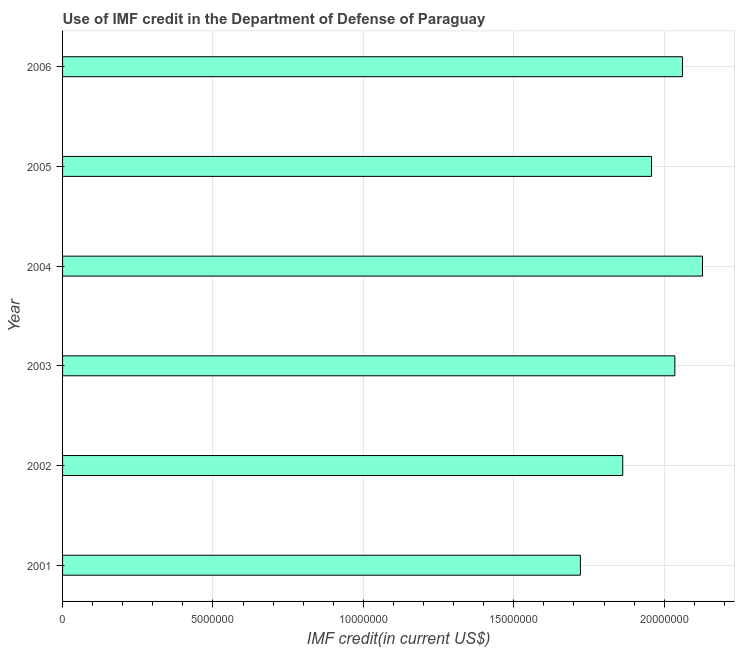Does the graph contain any zero values?
Offer a terse response. No. Does the graph contain grids?
Offer a terse response. Yes. What is the title of the graph?
Ensure brevity in your answer.  Use of IMF credit in the Department of Defense of Paraguay. What is the label or title of the X-axis?
Offer a very short reply. IMF credit(in current US$). What is the use of imf credit in dod in 2001?
Provide a succinct answer. 1.72e+07. Across all years, what is the maximum use of imf credit in dod?
Your answer should be very brief. 2.13e+07. Across all years, what is the minimum use of imf credit in dod?
Give a very brief answer. 1.72e+07. In which year was the use of imf credit in dod maximum?
Your response must be concise. 2004. What is the sum of the use of imf credit in dod?
Give a very brief answer. 1.18e+08. What is the difference between the use of imf credit in dod in 2003 and 2004?
Provide a succinct answer. -9.19e+05. What is the average use of imf credit in dod per year?
Provide a succinct answer. 1.96e+07. What is the median use of imf credit in dod?
Keep it short and to the point. 2.00e+07. In how many years, is the use of imf credit in dod greater than 18000000 US$?
Offer a terse response. 5. What is the ratio of the use of imf credit in dod in 2002 to that in 2004?
Provide a succinct answer. 0.88. Is the difference between the use of imf credit in dod in 2004 and 2006 greater than the difference between any two years?
Give a very brief answer. No. What is the difference between the highest and the second highest use of imf credit in dod?
Offer a very short reply. 6.66e+05. What is the difference between the highest and the lowest use of imf credit in dod?
Ensure brevity in your answer.  4.06e+06. In how many years, is the use of imf credit in dod greater than the average use of imf credit in dod taken over all years?
Give a very brief answer. 3. How many bars are there?
Make the answer very short. 6. How many years are there in the graph?
Your response must be concise. 6. What is the IMF credit(in current US$) of 2001?
Keep it short and to the point. 1.72e+07. What is the IMF credit(in current US$) in 2002?
Make the answer very short. 1.86e+07. What is the IMF credit(in current US$) in 2003?
Your response must be concise. 2.04e+07. What is the IMF credit(in current US$) in 2004?
Provide a short and direct response. 2.13e+07. What is the IMF credit(in current US$) in 2005?
Your answer should be very brief. 1.96e+07. What is the IMF credit(in current US$) of 2006?
Ensure brevity in your answer.  2.06e+07. What is the difference between the IMF credit(in current US$) in 2001 and 2002?
Your response must be concise. -1.41e+06. What is the difference between the IMF credit(in current US$) in 2001 and 2003?
Offer a terse response. -3.14e+06. What is the difference between the IMF credit(in current US$) in 2001 and 2004?
Keep it short and to the point. -4.06e+06. What is the difference between the IMF credit(in current US$) in 2001 and 2005?
Make the answer very short. -2.36e+06. What is the difference between the IMF credit(in current US$) in 2001 and 2006?
Your answer should be compact. -3.39e+06. What is the difference between the IMF credit(in current US$) in 2002 and 2003?
Provide a succinct answer. -1.73e+06. What is the difference between the IMF credit(in current US$) in 2002 and 2004?
Provide a succinct answer. -2.65e+06. What is the difference between the IMF credit(in current US$) in 2002 and 2005?
Your answer should be very brief. -9.56e+05. What is the difference between the IMF credit(in current US$) in 2002 and 2006?
Your answer should be very brief. -1.98e+06. What is the difference between the IMF credit(in current US$) in 2003 and 2004?
Ensure brevity in your answer.  -9.19e+05. What is the difference between the IMF credit(in current US$) in 2003 and 2005?
Your answer should be compact. 7.76e+05. What is the difference between the IMF credit(in current US$) in 2003 and 2006?
Provide a succinct answer. -2.53e+05. What is the difference between the IMF credit(in current US$) in 2004 and 2005?
Provide a short and direct response. 1.70e+06. What is the difference between the IMF credit(in current US$) in 2004 and 2006?
Your answer should be compact. 6.66e+05. What is the difference between the IMF credit(in current US$) in 2005 and 2006?
Your answer should be very brief. -1.03e+06. What is the ratio of the IMF credit(in current US$) in 2001 to that in 2002?
Make the answer very short. 0.92. What is the ratio of the IMF credit(in current US$) in 2001 to that in 2003?
Your response must be concise. 0.85. What is the ratio of the IMF credit(in current US$) in 2001 to that in 2004?
Provide a succinct answer. 0.81. What is the ratio of the IMF credit(in current US$) in 2001 to that in 2005?
Give a very brief answer. 0.88. What is the ratio of the IMF credit(in current US$) in 2001 to that in 2006?
Your answer should be very brief. 0.83. What is the ratio of the IMF credit(in current US$) in 2002 to that in 2003?
Your answer should be very brief. 0.92. What is the ratio of the IMF credit(in current US$) in 2002 to that in 2004?
Make the answer very short. 0.88. What is the ratio of the IMF credit(in current US$) in 2002 to that in 2005?
Offer a terse response. 0.95. What is the ratio of the IMF credit(in current US$) in 2002 to that in 2006?
Offer a very short reply. 0.9. What is the ratio of the IMF credit(in current US$) in 2003 to that in 2005?
Make the answer very short. 1.04. What is the ratio of the IMF credit(in current US$) in 2004 to that in 2005?
Make the answer very short. 1.09. What is the ratio of the IMF credit(in current US$) in 2004 to that in 2006?
Offer a very short reply. 1.03. What is the ratio of the IMF credit(in current US$) in 2005 to that in 2006?
Provide a short and direct response. 0.95. 